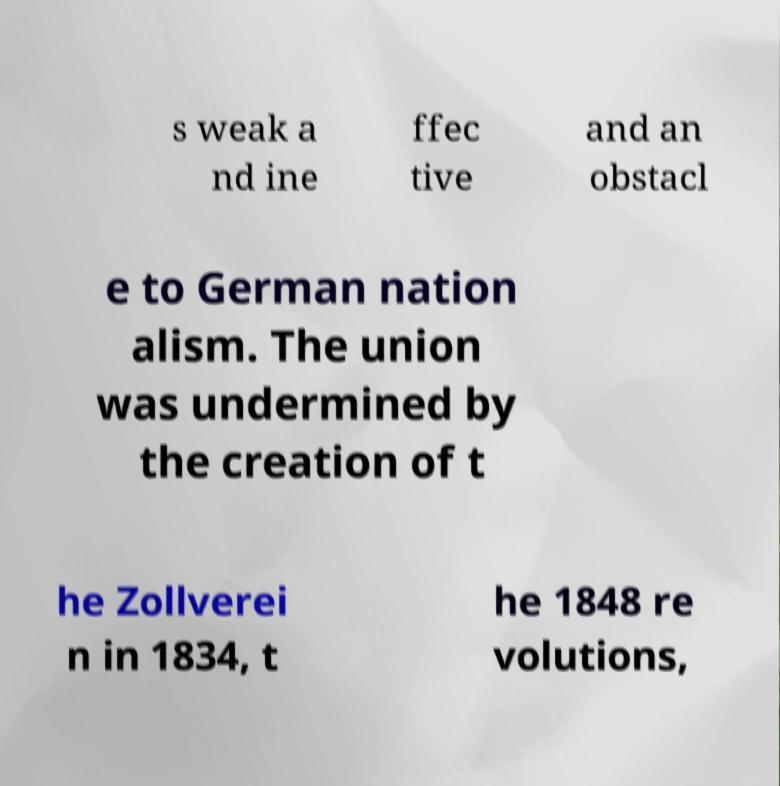Could you extract and type out the text from this image? s weak a nd ine ffec tive and an obstacl e to German nation alism. The union was undermined by the creation of t he Zollverei n in 1834, t he 1848 re volutions, 